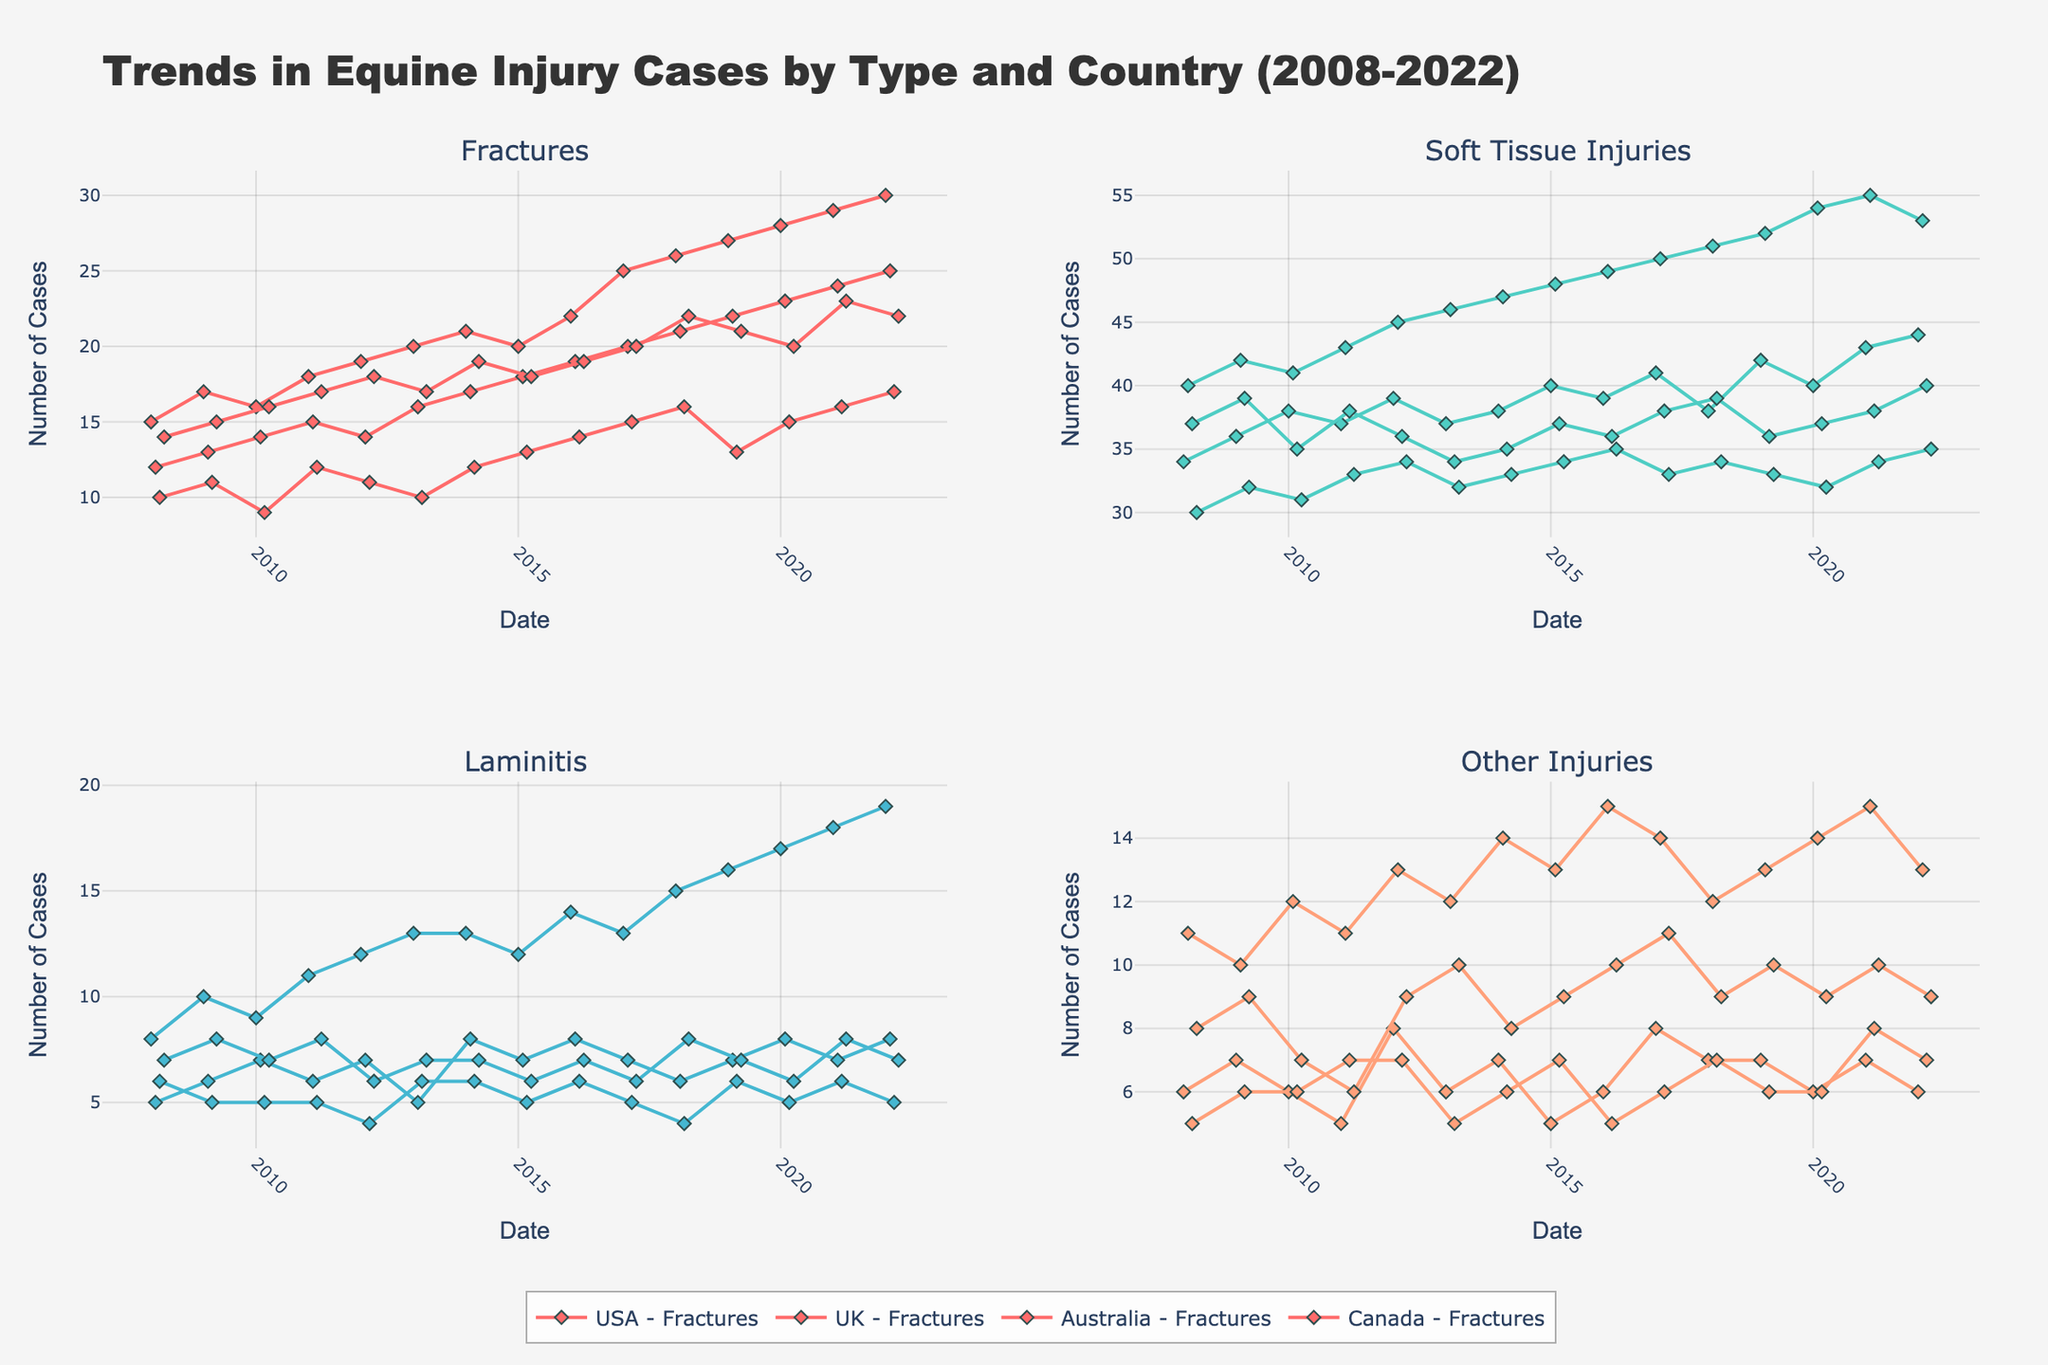What is the title of the figure? The title is located at the top of the figure and indicates the main subject of the analysis. The title text should be written in bold.
Answer: Trends in Equine Injury Cases by Type and Country (2008-2022) Which country had the highest number of 'Fractures' in Winter 2022? Look at the subplot for 'Fractures' and find the data point for Winter 2022. Compare the 'Fractures' values for different countries.
Answer: USA In which season and year did 'Soft Tissue Injuries' peak in the UK? Locate the subplot for 'Soft Tissue Injuries', find the data points for the UK, and identify the point with the highest value.
Answer: Spring 2021 How do the number of 'Laminitis' cases in Summer compare to those in Winter across the data period? Examine the 'Laminitis' subplot, compare the values for Summer and Winter over the years and determine which season generally has higher values.
Answer: Winter generally has higher cases of 'Laminitis' than Summer What is the overall trend in 'Other Injuries' in Canada from 2008 to 2022? Look at the 'Other Injuries' subplot for Canada, observe the direction of the data points over time, and describe the trend.
Answer: The trend is relatively stable with slight fluctuations On average, which country reports more 'Fractures': Australia or Canada? Calculate the average number of 'Fractures' for Australia and Canada by summing their respective data points across all years and dividing by the number of points.
Answer: Canada Between 2010 and 2015, which injury type showed the most significant increase in cases in the USA? For each injury type, calculate the difference in the number of cases between 2010 and 2015 in the USA and identify the type with the largest increase.
Answer: 'Soft Tissue Injuries' During which quarter of a typical year do 'Soft Tissue Injuries' peak in the dataset? Examine the 'Soft Tissue Injuries' subplot and identify the quarter with the highest data points by visual inspection.
Answer: Q2 (Spring) Are 'Laminitis' cases more common in the UK or Australia? Compare the overall number of 'Laminitis' cases in the UK and Australia by observing the respective subplots and summing up the values for each country.
Answer: UK What is the trend for 'Fractures' in Australia during the summer from 2008 to 2022? Focus on the 'Fractures' subplot for Australia, specifically over the summer months each year, and describe whether the trend is increasing, decreasing, or stable.
Answer: The trend is relatively stable with minor fluctuations 